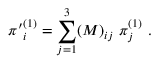<formula> <loc_0><loc_0><loc_500><loc_500>{ \pi ^ { \prime } } _ { i } ^ { ( 1 ) } = \sum _ { j = 1 } ^ { 3 } ( M ) _ { i j } \pi _ { j } ^ { ( 1 ) } .</formula> 